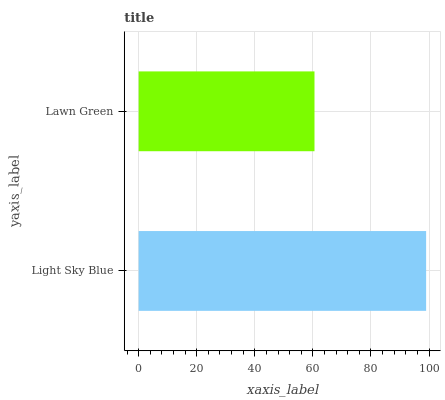Is Lawn Green the minimum?
Answer yes or no. Yes. Is Light Sky Blue the maximum?
Answer yes or no. Yes. Is Lawn Green the maximum?
Answer yes or no. No. Is Light Sky Blue greater than Lawn Green?
Answer yes or no. Yes. Is Lawn Green less than Light Sky Blue?
Answer yes or no. Yes. Is Lawn Green greater than Light Sky Blue?
Answer yes or no. No. Is Light Sky Blue less than Lawn Green?
Answer yes or no. No. Is Light Sky Blue the high median?
Answer yes or no. Yes. Is Lawn Green the low median?
Answer yes or no. Yes. Is Lawn Green the high median?
Answer yes or no. No. Is Light Sky Blue the low median?
Answer yes or no. No. 